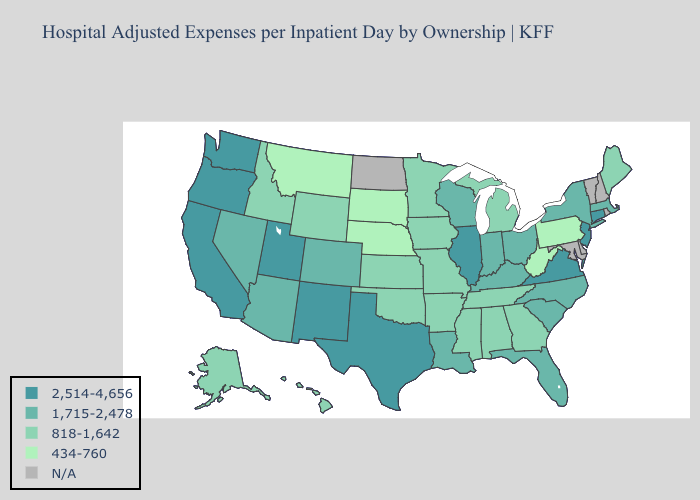Does the map have missing data?
Write a very short answer. Yes. What is the highest value in states that border Arkansas?
Write a very short answer. 2,514-4,656. What is the lowest value in states that border Tennessee?
Give a very brief answer. 818-1,642. Which states have the lowest value in the USA?
Write a very short answer. Montana, Nebraska, Pennsylvania, South Dakota, West Virginia. Among the states that border Utah , does New Mexico have the lowest value?
Short answer required. No. What is the value of Arizona?
Be succinct. 1,715-2,478. What is the value of New York?
Give a very brief answer. 1,715-2,478. Which states have the highest value in the USA?
Write a very short answer. California, Connecticut, Illinois, New Jersey, New Mexico, Oregon, Texas, Utah, Virginia, Washington. How many symbols are there in the legend?
Keep it brief. 5. Does Arizona have the lowest value in the West?
Be succinct. No. Name the states that have a value in the range N/A?
Write a very short answer. Delaware, Maryland, New Hampshire, North Dakota, Rhode Island, Vermont. What is the highest value in the USA?
Answer briefly. 2,514-4,656. Name the states that have a value in the range 2,514-4,656?
Keep it brief. California, Connecticut, Illinois, New Jersey, New Mexico, Oregon, Texas, Utah, Virginia, Washington. Name the states that have a value in the range 818-1,642?
Answer briefly. Alabama, Alaska, Arkansas, Georgia, Hawaii, Idaho, Iowa, Kansas, Maine, Michigan, Minnesota, Mississippi, Missouri, Oklahoma, Tennessee, Wyoming. What is the value of Nevada?
Short answer required. 1,715-2,478. 